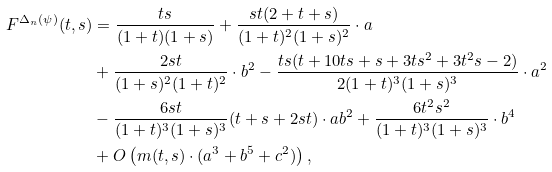<formula> <loc_0><loc_0><loc_500><loc_500>F ^ { \Delta _ { n } ( \psi ) } ( t , s ) & = \frac { t s } { ( 1 + t ) ( 1 + s ) } + \frac { s t ( 2 + t + s ) } { ( 1 + t ) ^ { 2 } ( 1 + s ) ^ { 2 } } \cdot a \\ & + \frac { 2 s t } { ( 1 + s ) ^ { 2 } ( 1 + t ) ^ { 2 } } \cdot b ^ { 2 } - \frac { t s ( t + 1 0 t s + s + 3 t s ^ { 2 } + 3 t ^ { 2 } s - 2 ) } { 2 ( 1 + t ) ^ { 3 } ( 1 + s ) ^ { 3 } } \cdot a ^ { 2 } \\ & - \frac { 6 s t } { ( 1 + t ) ^ { 3 } ( 1 + s ) ^ { 3 } } ( t + s + 2 s t ) \cdot a b ^ { 2 } + \frac { 6 t ^ { 2 } s ^ { 2 } } { ( 1 + t ) ^ { 3 } ( 1 + s ) ^ { 3 } } \cdot b ^ { 4 } \\ & + O \left ( m ( t , s ) \cdot ( a ^ { 3 } + b ^ { 5 } + c ^ { 2 } ) \right ) ,</formula> 